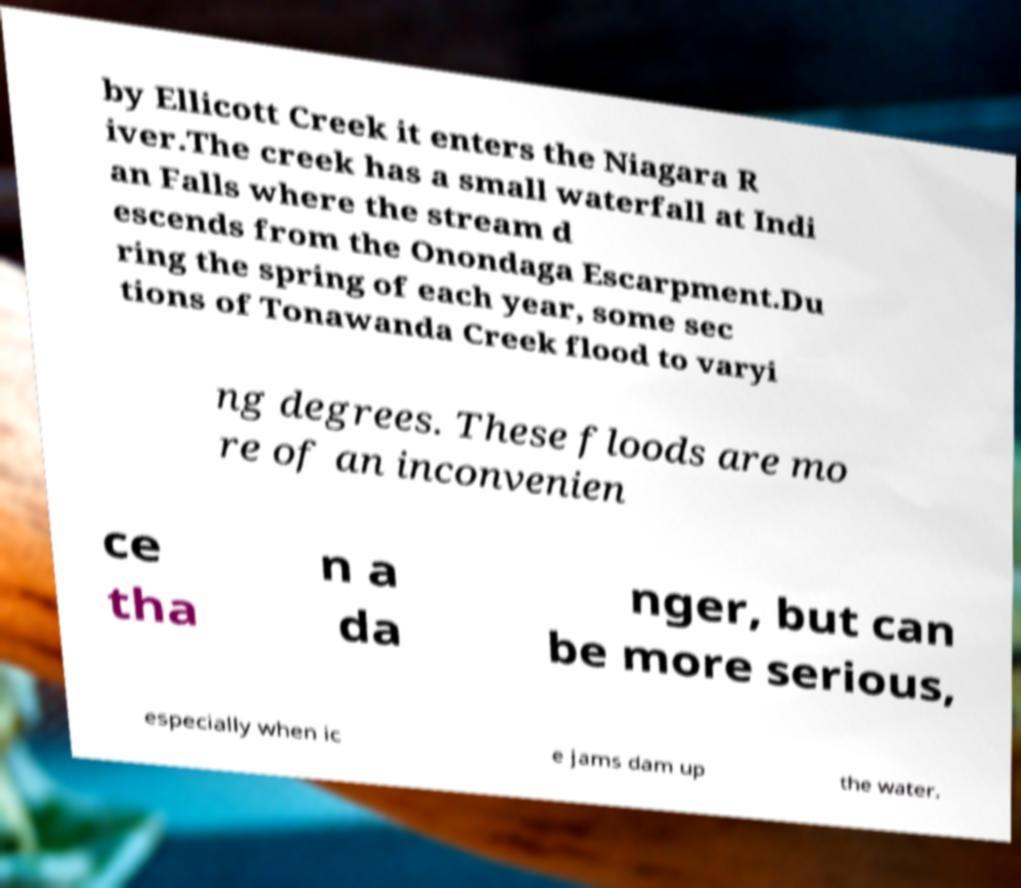Can you accurately transcribe the text from the provided image for me? by Ellicott Creek it enters the Niagara R iver.The creek has a small waterfall at Indi an Falls where the stream d escends from the Onondaga Escarpment.Du ring the spring of each year, some sec tions of Tonawanda Creek flood to varyi ng degrees. These floods are mo re of an inconvenien ce tha n a da nger, but can be more serious, especially when ic e jams dam up the water. 